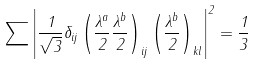Convert formula to latex. <formula><loc_0><loc_0><loc_500><loc_500>\sum \left | \frac { 1 } { \sqrt { 3 } } \delta _ { i j } \left ( \frac { \lambda ^ { a } } { 2 } \frac { \lambda ^ { b } } { 2 } \right ) _ { i j } \left ( \frac { \lambda ^ { b } } { 2 } \right ) _ { k l } \right | ^ { 2 } = \frac { 1 } { 3 }</formula> 